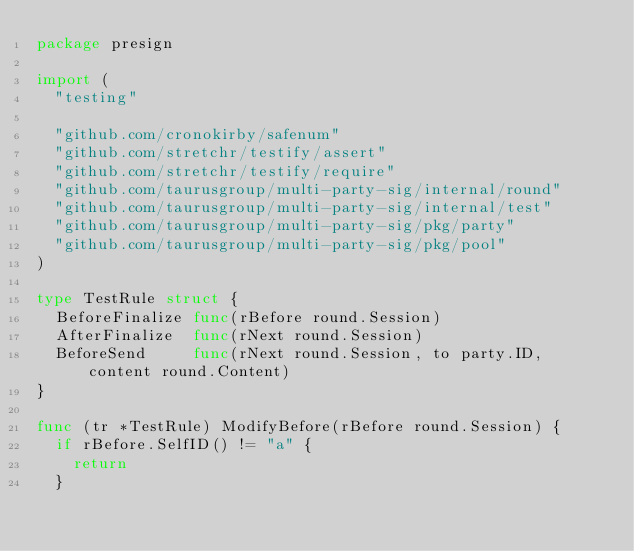<code> <loc_0><loc_0><loc_500><loc_500><_Go_>package presign

import (
	"testing"

	"github.com/cronokirby/safenum"
	"github.com/stretchr/testify/assert"
	"github.com/stretchr/testify/require"
	"github.com/taurusgroup/multi-party-sig/internal/round"
	"github.com/taurusgroup/multi-party-sig/internal/test"
	"github.com/taurusgroup/multi-party-sig/pkg/party"
	"github.com/taurusgroup/multi-party-sig/pkg/pool"
)

type TestRule struct {
	BeforeFinalize func(rBefore round.Session)
	AfterFinalize  func(rNext round.Session)
	BeforeSend     func(rNext round.Session, to party.ID, content round.Content)
}

func (tr *TestRule) ModifyBefore(rBefore round.Session) {
	if rBefore.SelfID() != "a" {
		return
	}</code> 